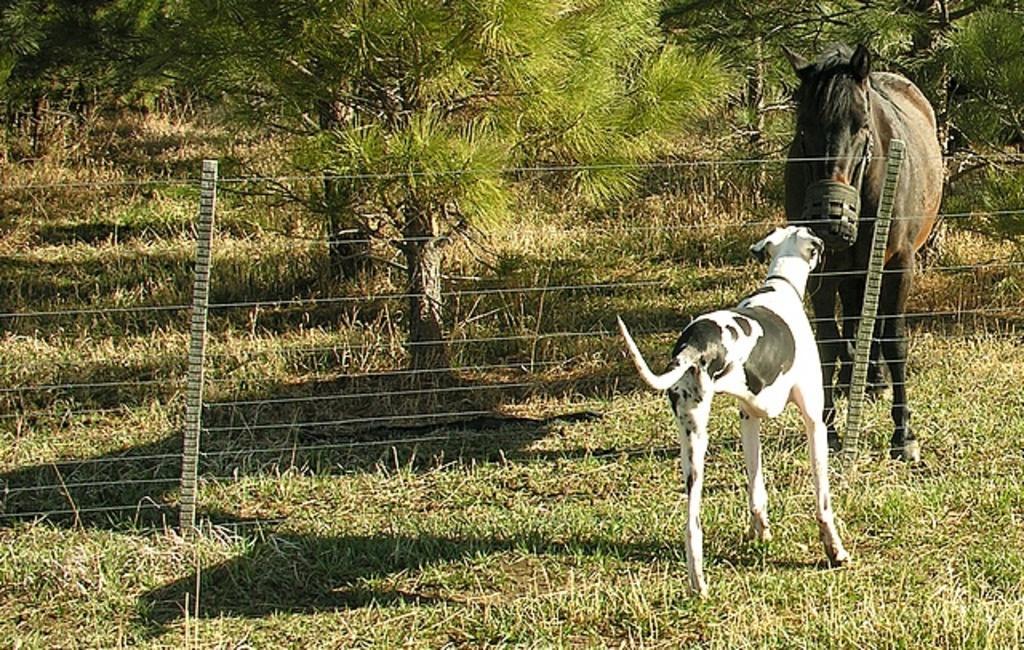Could you give a brief overview of what you see in this image? In this picture we can see animals on the ground and in the background we can see trees. 